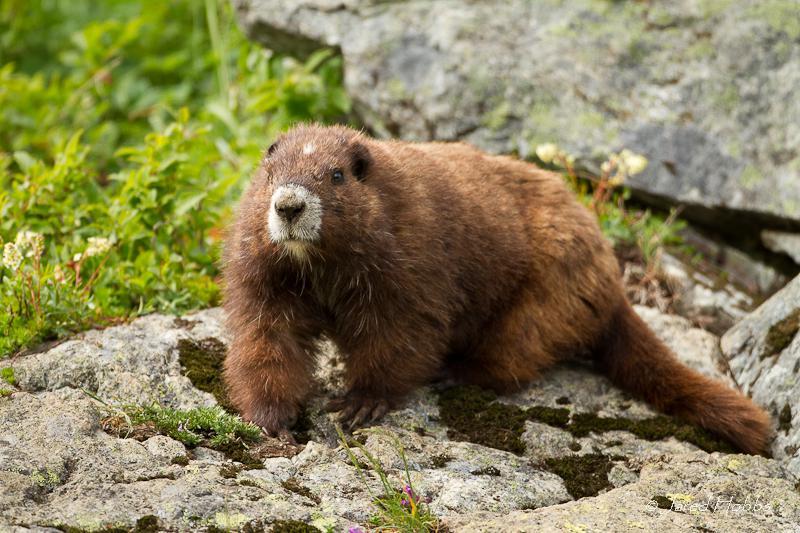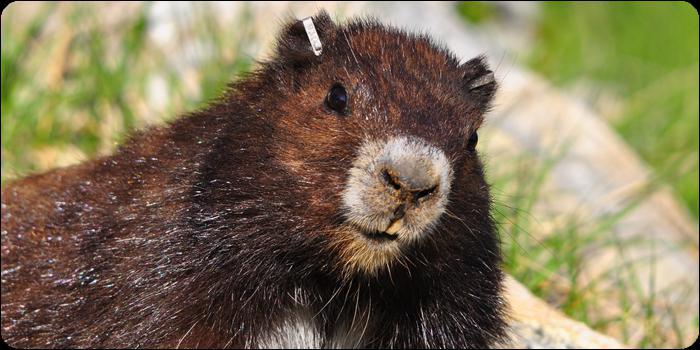The first image is the image on the left, the second image is the image on the right. Assess this claim about the two images: "One image depicts an adult animal and at least one younger rodent.". Correct or not? Answer yes or no. No. 